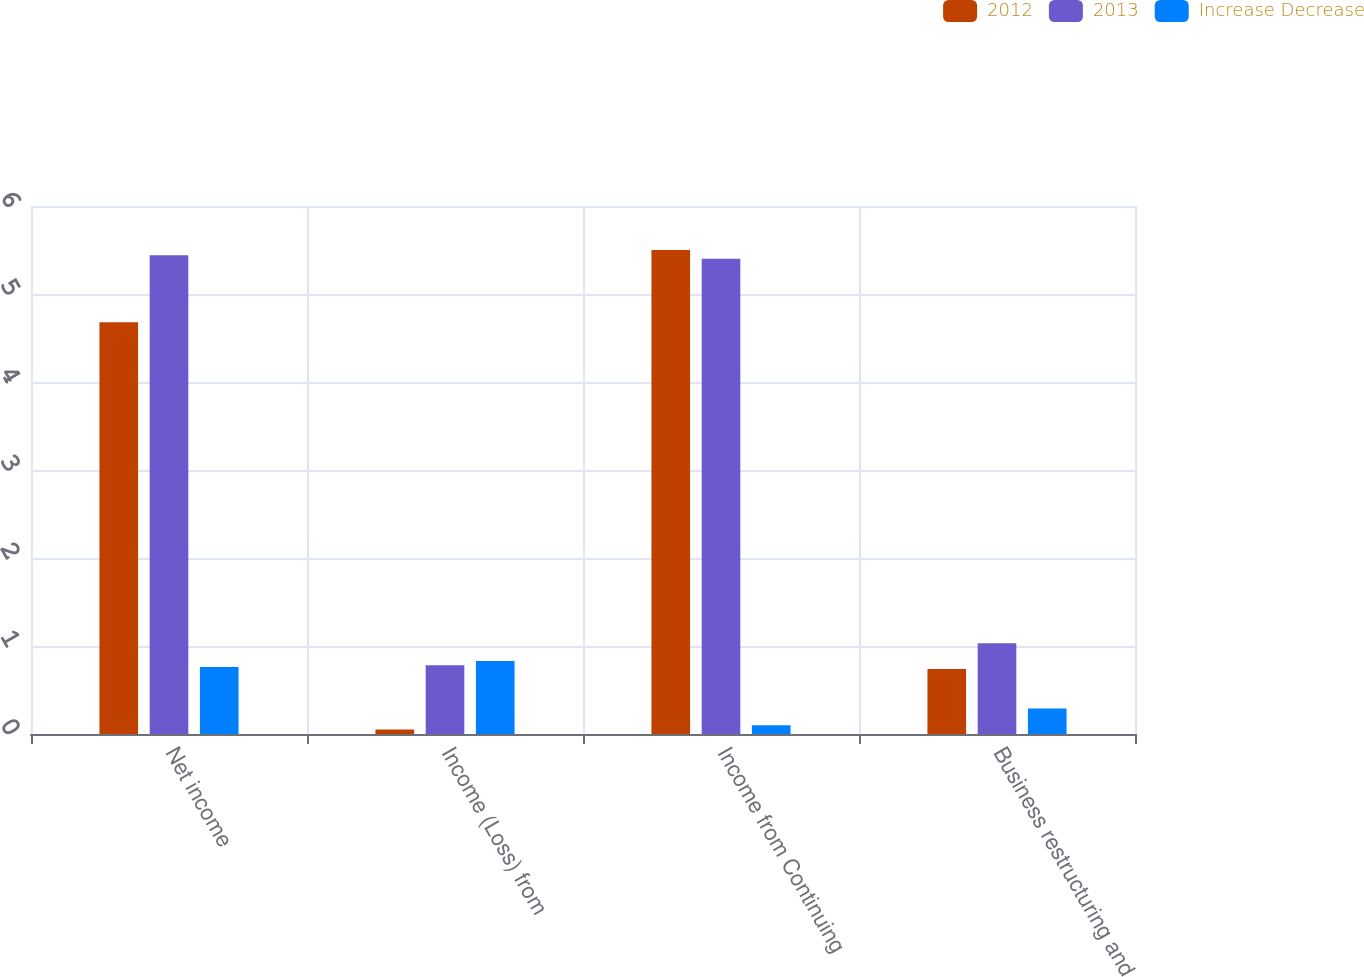Convert chart to OTSL. <chart><loc_0><loc_0><loc_500><loc_500><stacked_bar_chart><ecel><fcel>Net income<fcel>Income (Loss) from<fcel>Income from Continuing<fcel>Business restructuring and<nl><fcel>2012<fcel>4.68<fcel>0.05<fcel>5.5<fcel>0.74<nl><fcel>2013<fcel>5.44<fcel>0.78<fcel>5.4<fcel>1.03<nl><fcel>Increase Decrease<fcel>0.76<fcel>0.83<fcel>0.1<fcel>0.29<nl></chart> 